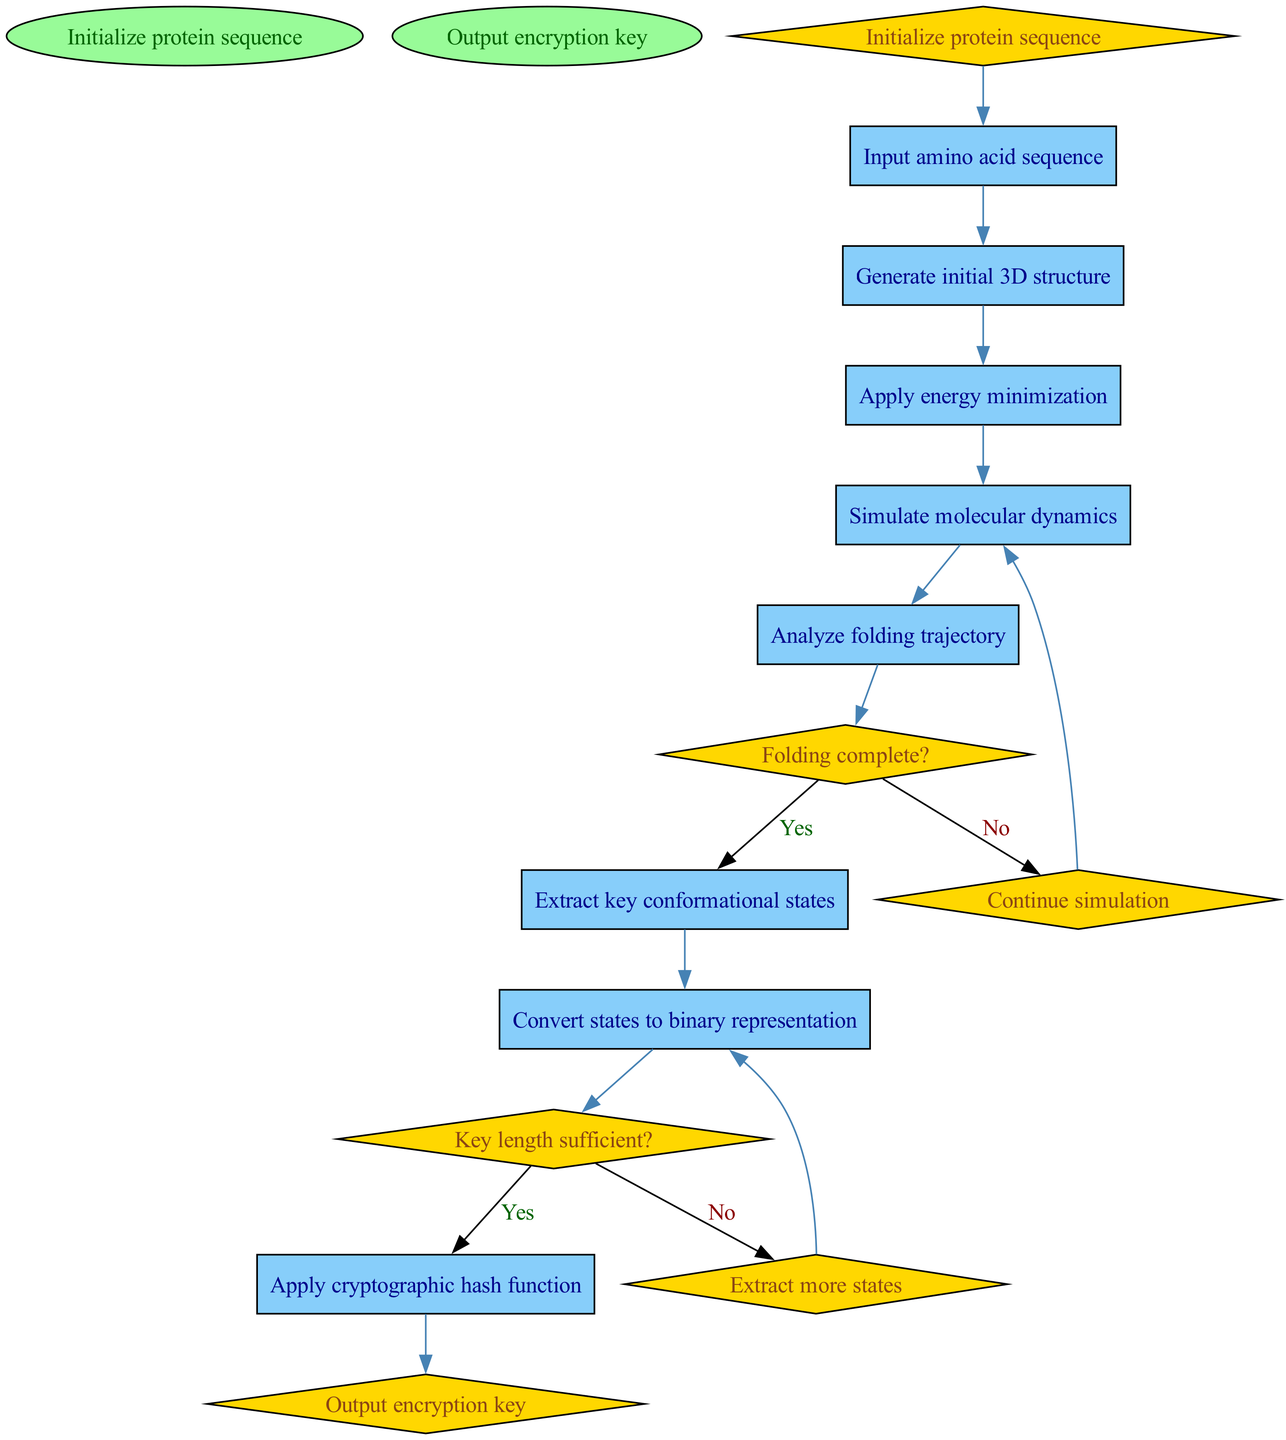What is the initial step in the process? The process starts with the "Initialize protein sequence" node, which is the first step before any other activities occur.
Answer: Initialize protein sequence How many decision nodes are in the diagram? There are two decision nodes, one for checking if the folding is complete and another for verifying if the key length is sufficient.
Answer: 2 What is the activity that follows "Simulate molecular dynamics"? The activity that follows "Simulate molecular dynamics" is "Analyze folding trajectory", according to the directional flow established in the diagram.
Answer: Analyze folding trajectory If the folding is not complete, what is the next action taken? If the folding is not complete, the process continues with "Continue simulation", leading back to the "Simulate molecular dynamics" node.
Answer: Continue simulation What is the final output of the diagram? The final output of the diagram is indicated by the "Output encryption key" node, which signifies the end of the process when the encryption key is generated.
Answer: Output encryption key What action is taken if more states need to be extracted? If more states need to be extracted, the process goes to "Extract more states", which is an additional step before converting states to binary representation.
Answer: Extract more states What decision leads to applying the cryptographic hash function? The decision that leads to applying the cryptographic hash function is whether the "Key length sufficient?" condition is met, confirming if the key length is adequate.
Answer: Key length sufficient? 